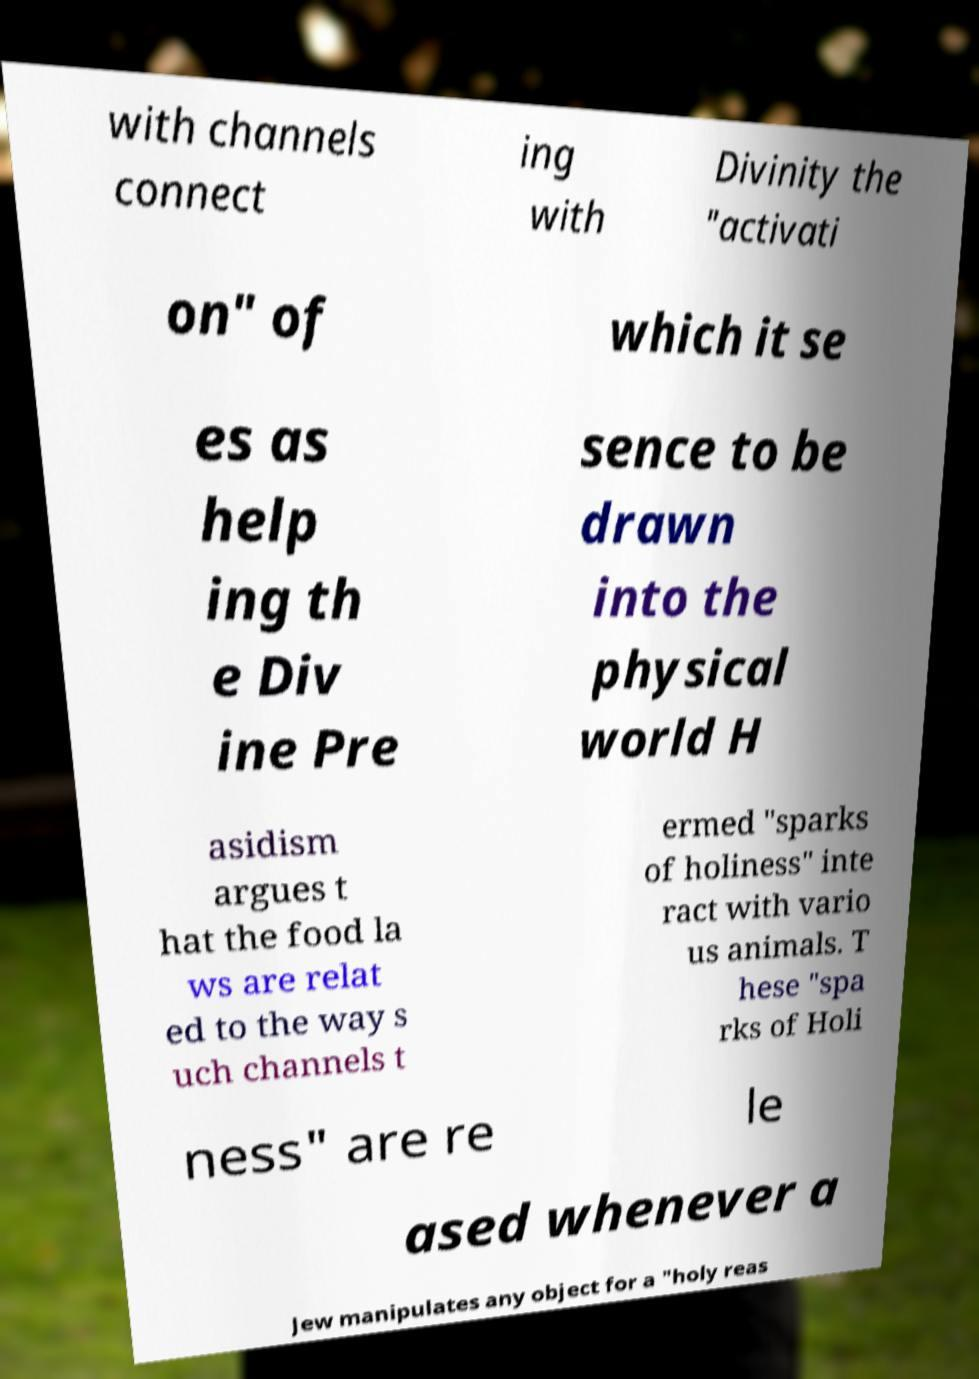For documentation purposes, I need the text within this image transcribed. Could you provide that? with channels connect ing with Divinity the "activati on" of which it se es as help ing th e Div ine Pre sence to be drawn into the physical world H asidism argues t hat the food la ws are relat ed to the way s uch channels t ermed "sparks of holiness" inte ract with vario us animals. T hese "spa rks of Holi ness" are re le ased whenever a Jew manipulates any object for a "holy reas 